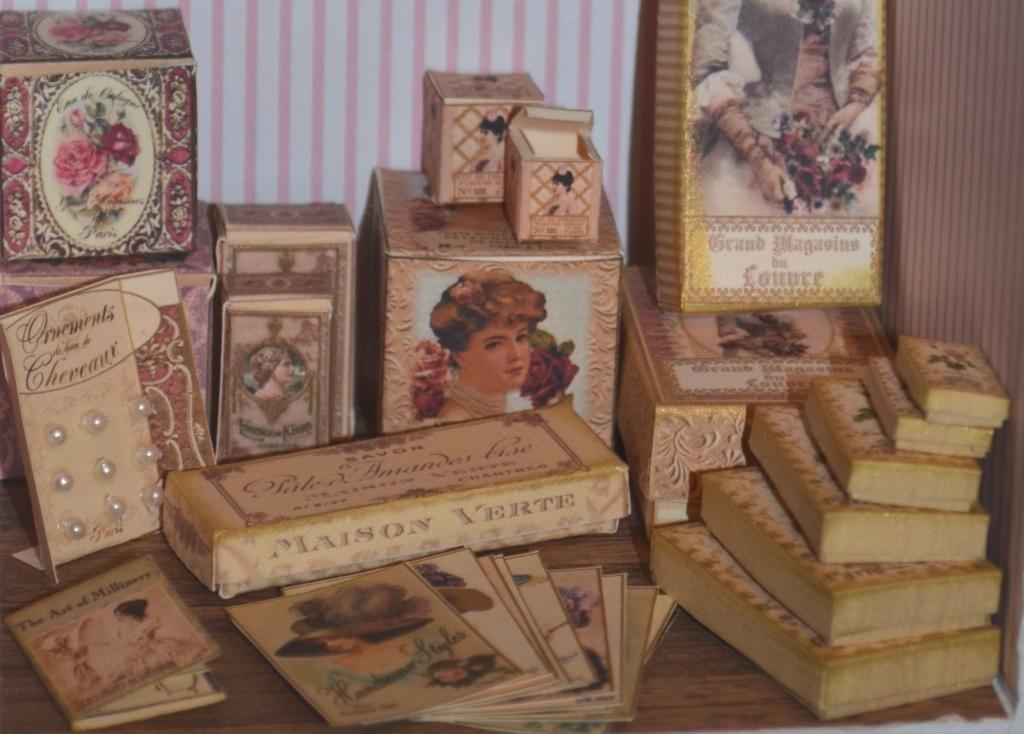What is the name on the box?
Offer a terse response. Maison verte. What is the design of wall paper on the wall?
Provide a succinct answer. Unanswerable. 